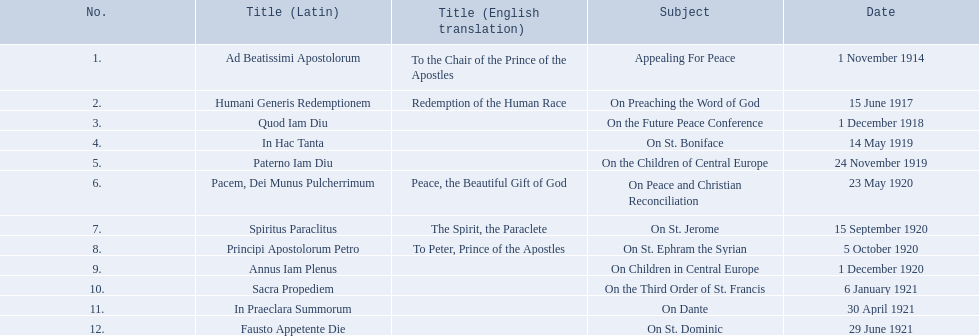What are all the fields? Appealing For Peace, On Preaching the Word of God, On the Future Peace Conference, On St. Boniface, On the Children of Central Europe, On Peace and Christian Reconciliation, On St. Jerome, On St. Ephram the Syrian, On Children in Central Europe, On the Third Order of St. Francis, On Dante, On St. Dominic. Which happened in 1920? On Peace and Christian Reconciliation, On St. Jerome, On St. Ephram the Syrian, On Children in Central Europe. Which took place in may of that year? On Peace and Christian Reconciliation. 